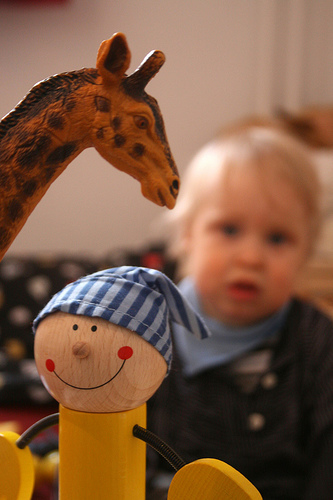<image>
Is there a toy above the toy? Yes. The toy is positioned above the toy in the vertical space, higher up in the scene. 